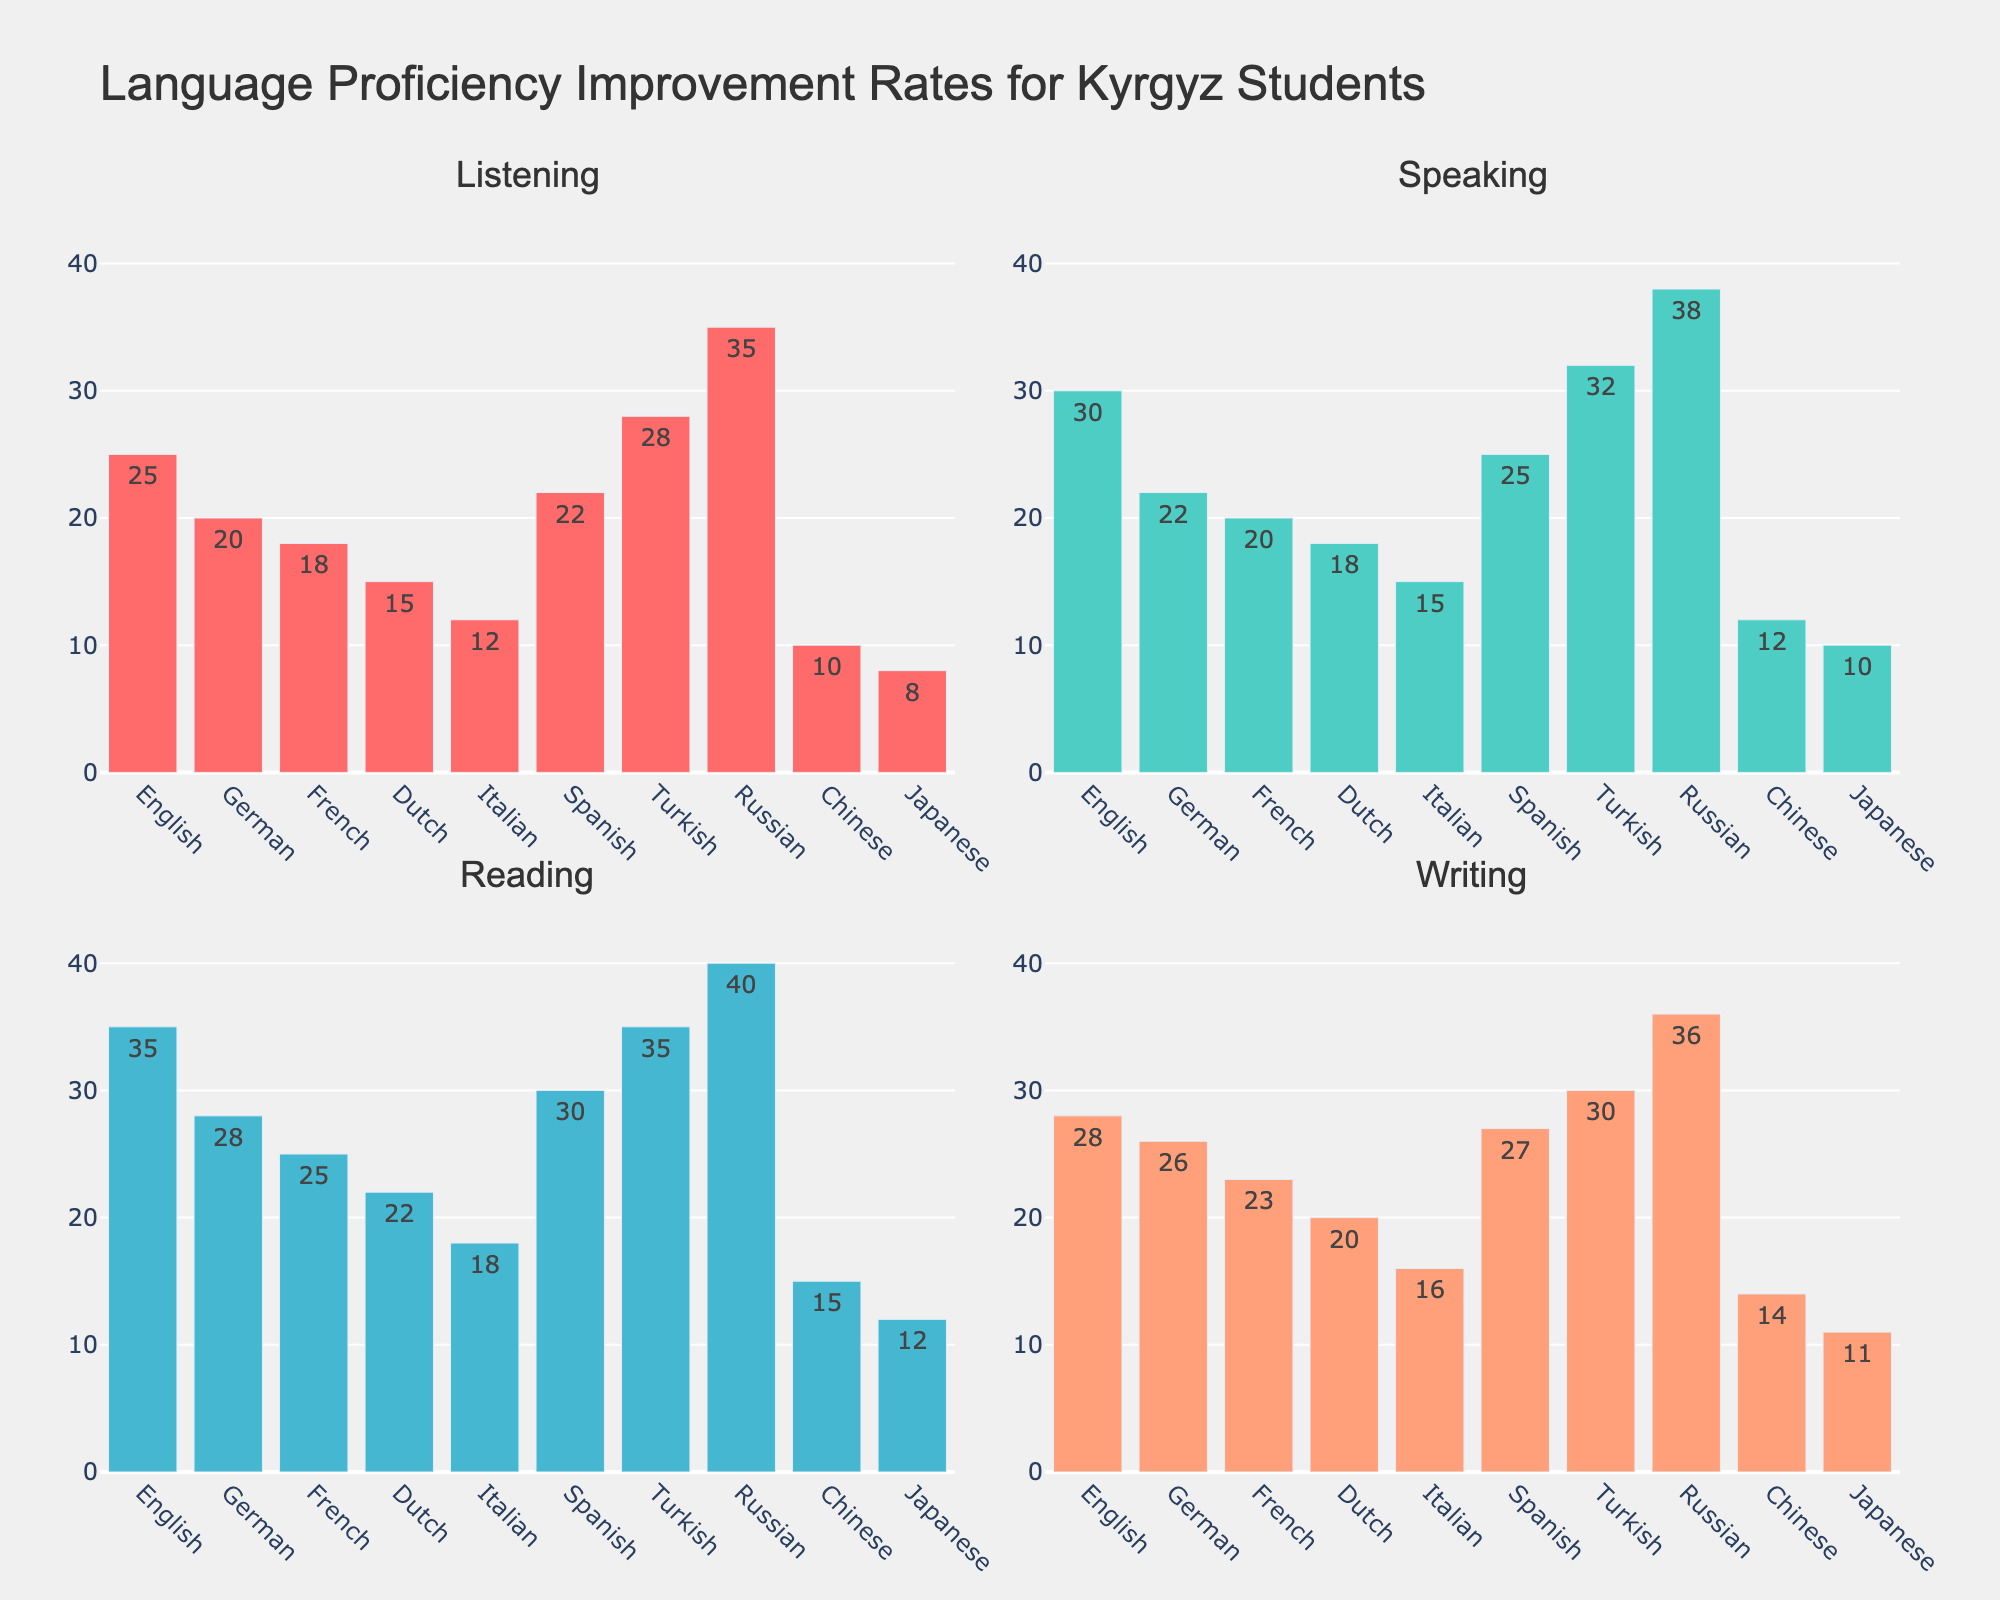How many subplots are there in total? There are 2 rows and 2 columns of subplots, so the total number of subplots is 2 * 2 = 4.
Answer: 4 What skill has the highest improvement rate in the Listening subplot? In the Listening subplot, the "Russian" bar is the highest with a rate of 35.
Answer: Russian Which language has the lowest proficiency improvement in Speaking? In the Speaking subplot, the "Japanese" bar is the shortest, indicating the lowest rate of 10.
Answer: Japanese What's the average improvement rate for Reading across all languages? Sum the Reading rates of all languages: 35 + 28 + 25 + 22 + 18 + 30 + 35 + 40 + 15 + 12 = 260. There are 10 languages, so the average is 260 / 10 = 26.
Answer: 26 How does the improvement in Listening for English compare with that for Chinese? The bar for English in Listening is at 25, and for Chinese, it is at 10. English has a higher improvement rate by 25 - 10 = 15.
Answer: English is higher by 15 Which language shows the greatest spread between the highest and lowest proficiency improvements across the skills? For each language, subtract the lowest value from the highest value across all skills: English: 35-25=10, German: 28-20=8, French: 25-18=7, Dutch: 22-15=7, Italian: 18-12=6, Spanish: 30-22=8, Turkish: 35-28=7, Russian: 40-35=5, Chinese: 15-10=5, Japanese: 12-8=4. The highest spread is for English with 10.
Answer: English Which subplots show the same language having the highest improvement rate? Russian has the highest rate in both the Reading and Speaking subplots.
Answer: Reading and Speaking 